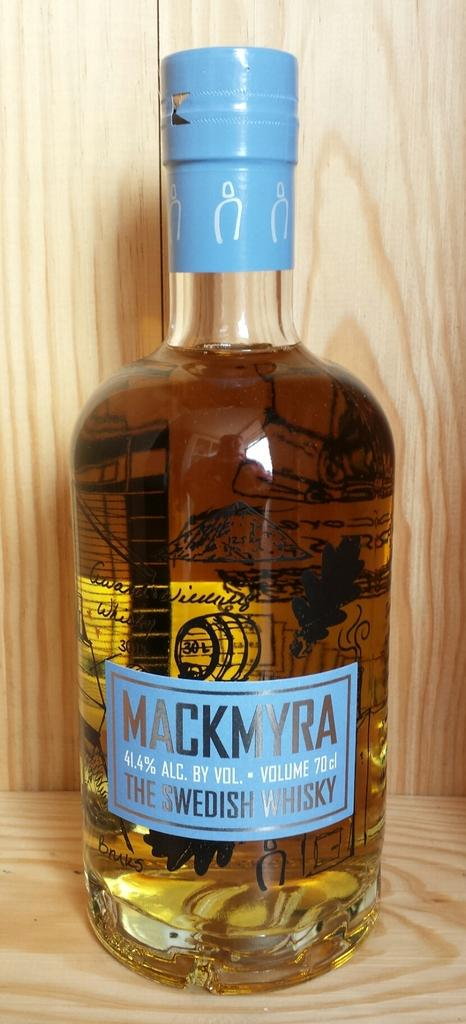<image>
Share a concise interpretation of the image provided. Mackmyra, the swedish whiskey stands on display in a wooden case 